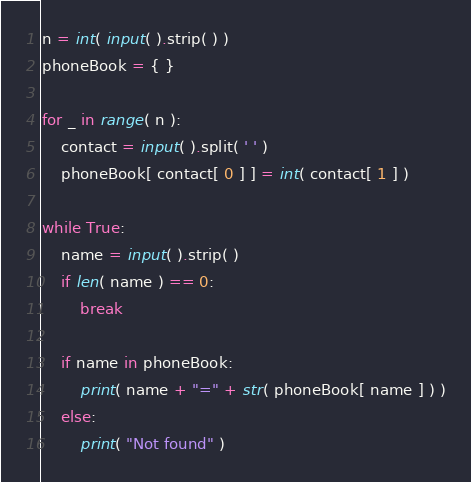<code> <loc_0><loc_0><loc_500><loc_500><_Python_>n = int( input( ).strip( ) )
phoneBook = { }

for _ in range( n ):
    contact = input( ).split( ' ' )
    phoneBook[ contact[ 0 ] ] = int( contact[ 1 ] )

while True:
    name = input( ).strip( )
    if len( name ) == 0:
        break
    
    if name in phoneBook:
        print( name + "=" + str( phoneBook[ name ] ) )
    else:
        print( "Not found" )
</code> 